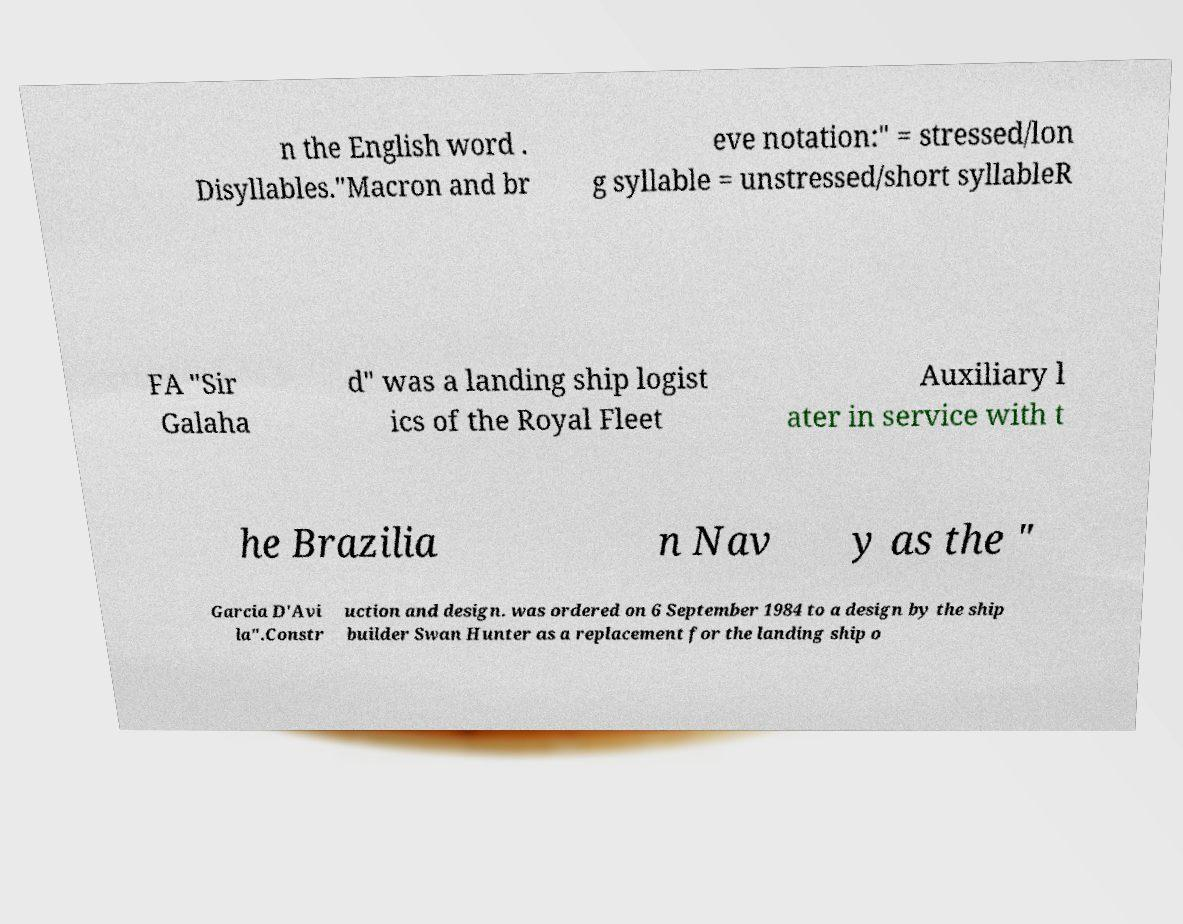For documentation purposes, I need the text within this image transcribed. Could you provide that? n the English word . Disyllables."Macron and br eve notation:" = stressed/lon g syllable = unstressed/short syllableR FA "Sir Galaha d" was a landing ship logist ics of the Royal Fleet Auxiliary l ater in service with t he Brazilia n Nav y as the " Garcia D'Avi la".Constr uction and design. was ordered on 6 September 1984 to a design by the ship builder Swan Hunter as a replacement for the landing ship o 